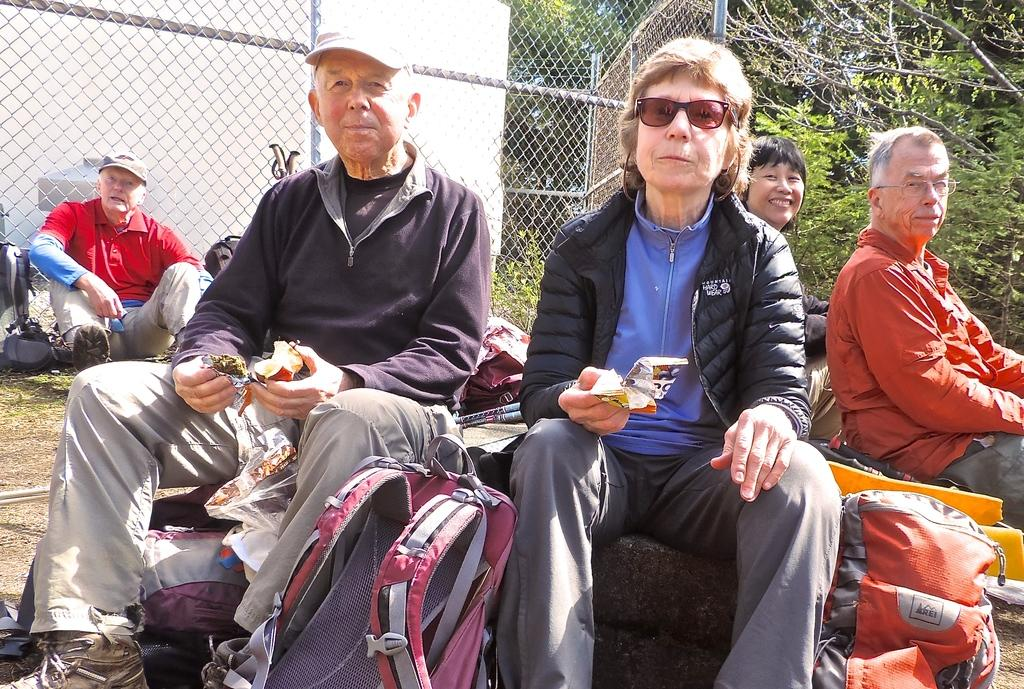What are the people in the image doing? There are many persons sitting on the ground with bags. What can be seen in the background of the image? There is fencing, at least one building, trees, and plants visible in the background of the image. What type of chin can be seen on the owner of the building in the image? There is no owner of the building visible in the image, and therefore no chin can be observed. 